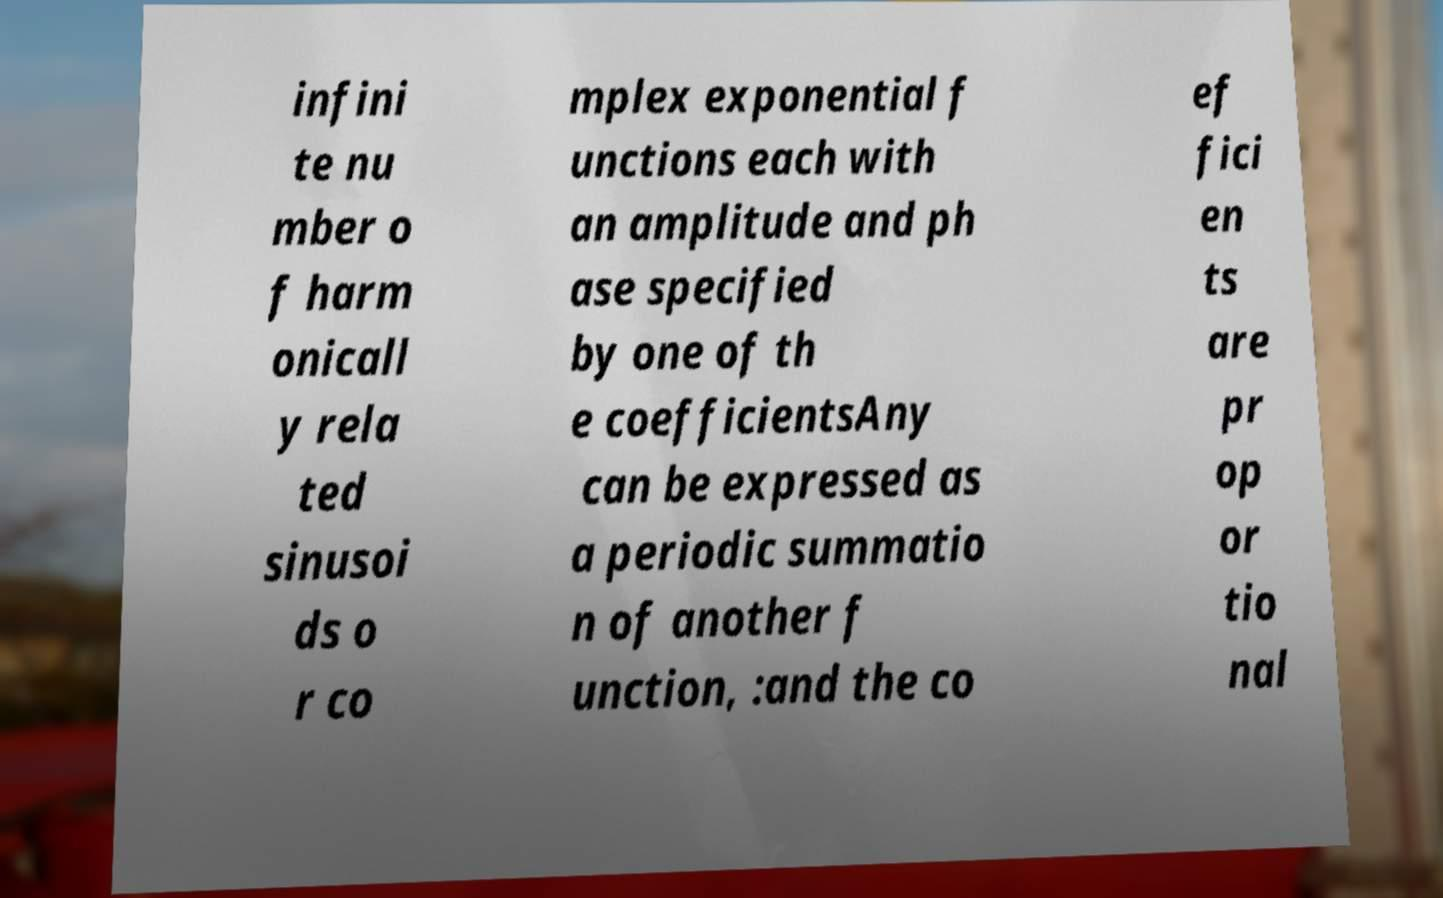What messages or text are displayed in this image? I need them in a readable, typed format. infini te nu mber o f harm onicall y rela ted sinusoi ds o r co mplex exponential f unctions each with an amplitude and ph ase specified by one of th e coefficientsAny can be expressed as a periodic summatio n of another f unction, :and the co ef fici en ts are pr op or tio nal 